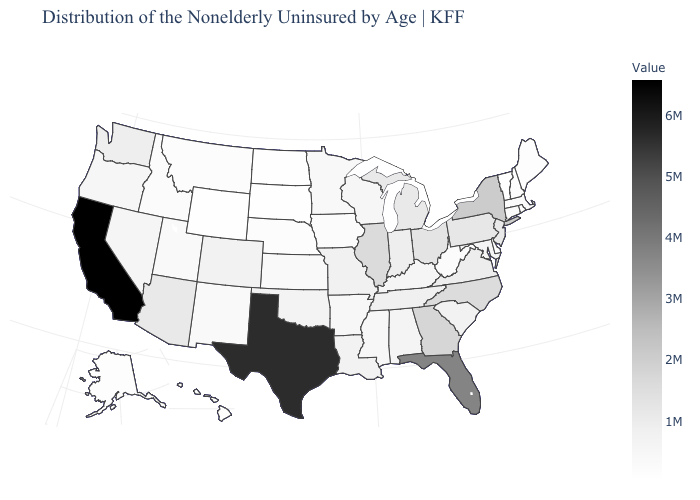Among the states that border Michigan , which have the lowest value?
Quick response, please. Wisconsin. Does Vermont have the lowest value in the USA?
Keep it brief. Yes. Among the states that border Iowa , which have the highest value?
Write a very short answer. Illinois. Does Vermont have the lowest value in the USA?
Keep it brief. Yes. Does Delaware have the highest value in the South?
Be succinct. No. Which states have the lowest value in the USA?
Give a very brief answer. Vermont. Does the map have missing data?
Short answer required. No. 